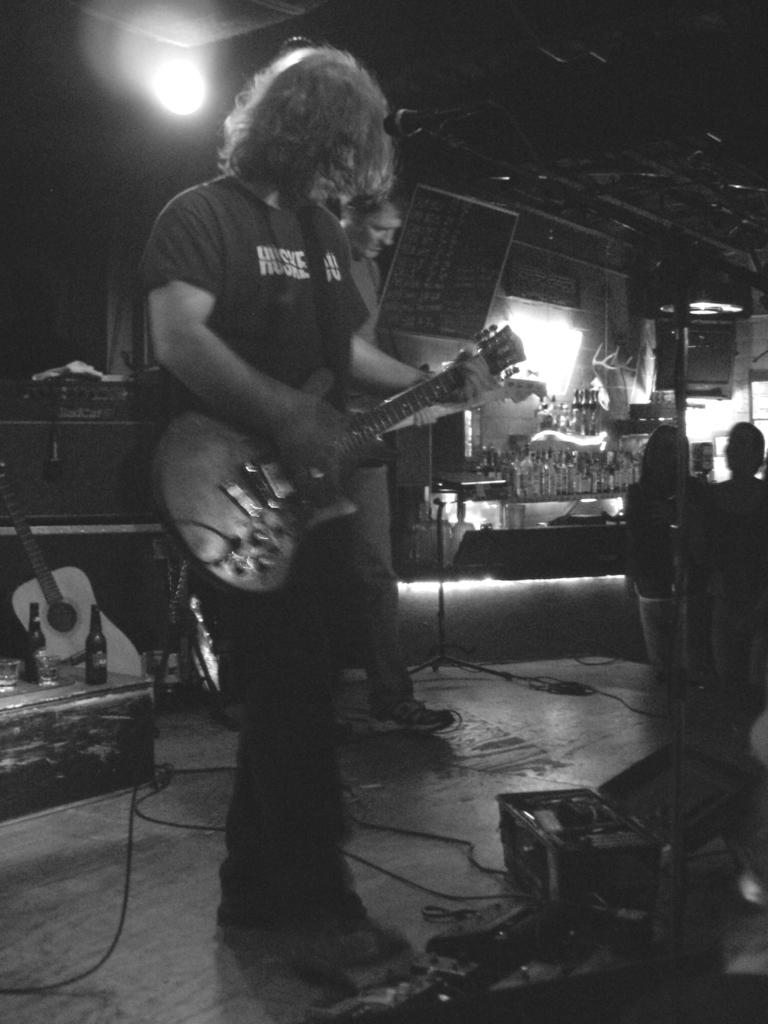How many people are performing on stage in the image? There are two people on the stage in the image. What are the performers on stage doing? The people on stage are playing guitar. Can you describe the audience in the image? There are people standing and looking at the performers on stage. What can be seen in the background of the image? There are wine bottles, guitars, and lighting in the background. What type of organization is being discussed in the prose of the image? There is no prose or discussion of an organization present in the image; it features two people playing guitar on stage. What is the shocking event that occurred during the performance in the image? There is no shocking event or any indication of a shocking event in the image; it simply shows two people playing guitar on stage. 